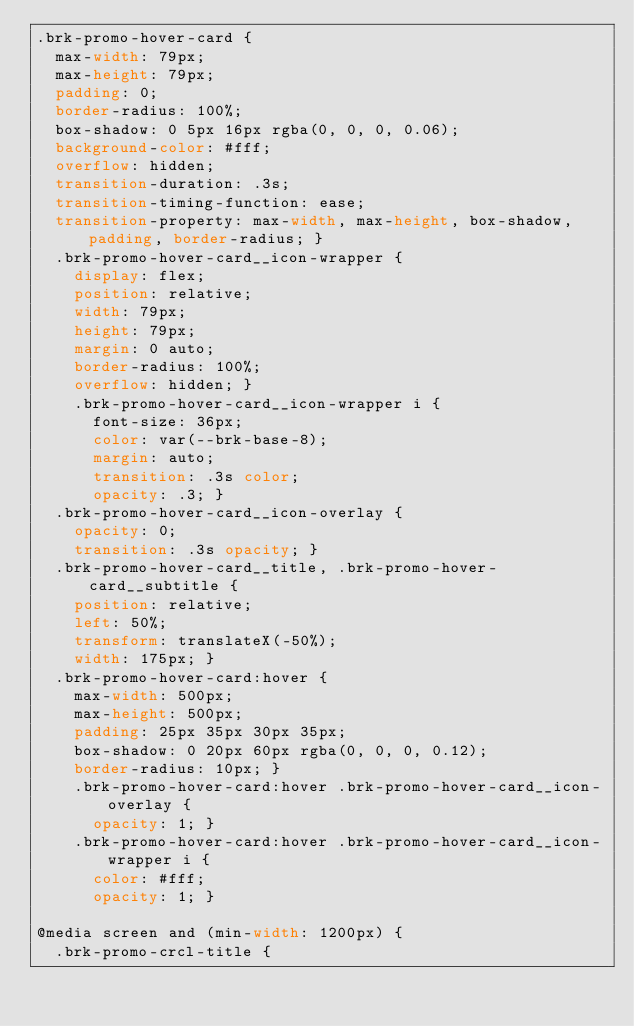<code> <loc_0><loc_0><loc_500><loc_500><_CSS_>.brk-promo-hover-card {
  max-width: 79px;
  max-height: 79px;
  padding: 0;
  border-radius: 100%;
  box-shadow: 0 5px 16px rgba(0, 0, 0, 0.06);
  background-color: #fff;
  overflow: hidden;
  transition-duration: .3s;
  transition-timing-function: ease;
  transition-property: max-width, max-height, box-shadow, padding, border-radius; }
  .brk-promo-hover-card__icon-wrapper {
    display: flex;
    position: relative;
    width: 79px;
    height: 79px;
    margin: 0 auto;
    border-radius: 100%;
    overflow: hidden; }
    .brk-promo-hover-card__icon-wrapper i {
      font-size: 36px;
      color: var(--brk-base-8);
      margin: auto;
      transition: .3s color;
      opacity: .3; }
  .brk-promo-hover-card__icon-overlay {
    opacity: 0;
    transition: .3s opacity; }
  .brk-promo-hover-card__title, .brk-promo-hover-card__subtitle {
    position: relative;
    left: 50%;
    transform: translateX(-50%);
    width: 175px; }
  .brk-promo-hover-card:hover {
    max-width: 500px;
    max-height: 500px;
    padding: 25px 35px 30px 35px;
    box-shadow: 0 20px 60px rgba(0, 0, 0, 0.12);
    border-radius: 10px; }
    .brk-promo-hover-card:hover .brk-promo-hover-card__icon-overlay {
      opacity: 1; }
    .brk-promo-hover-card:hover .brk-promo-hover-card__icon-wrapper i {
      color: #fff;
      opacity: 1; }

@media screen and (min-width: 1200px) {
  .brk-promo-crcl-title {</code> 